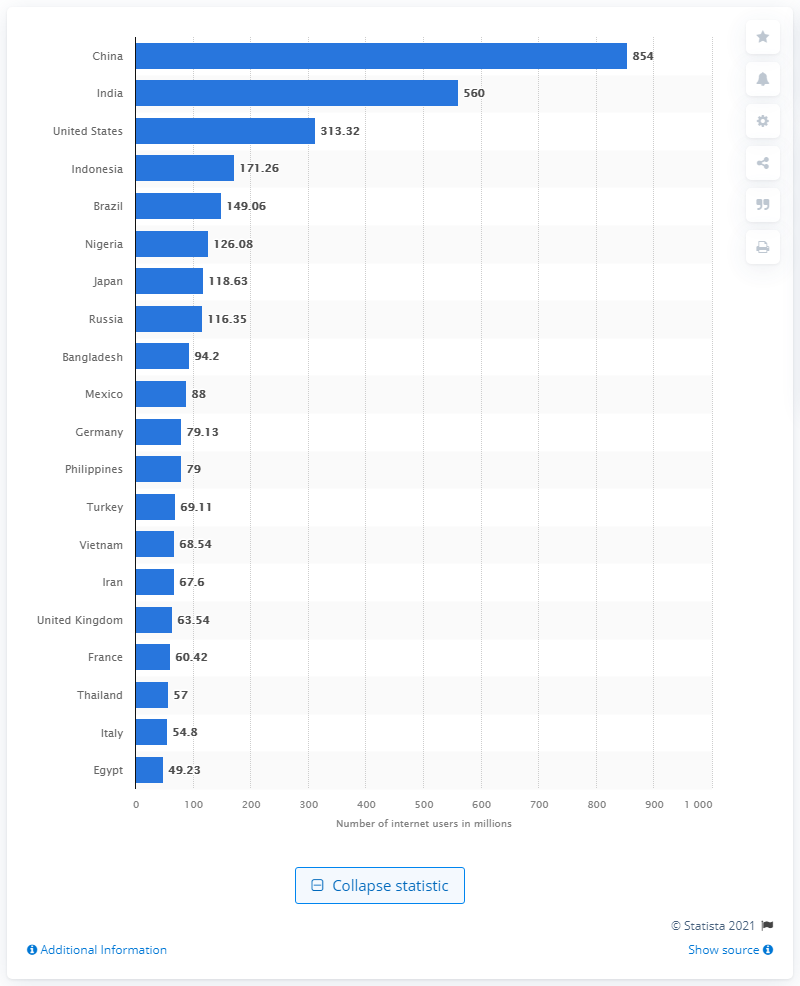Indicate a few pertinent items in this graphic. As of December 2019, China had a total of 854 million internet users. As of 2022, the United States had approximately 313.32 million internet users. 